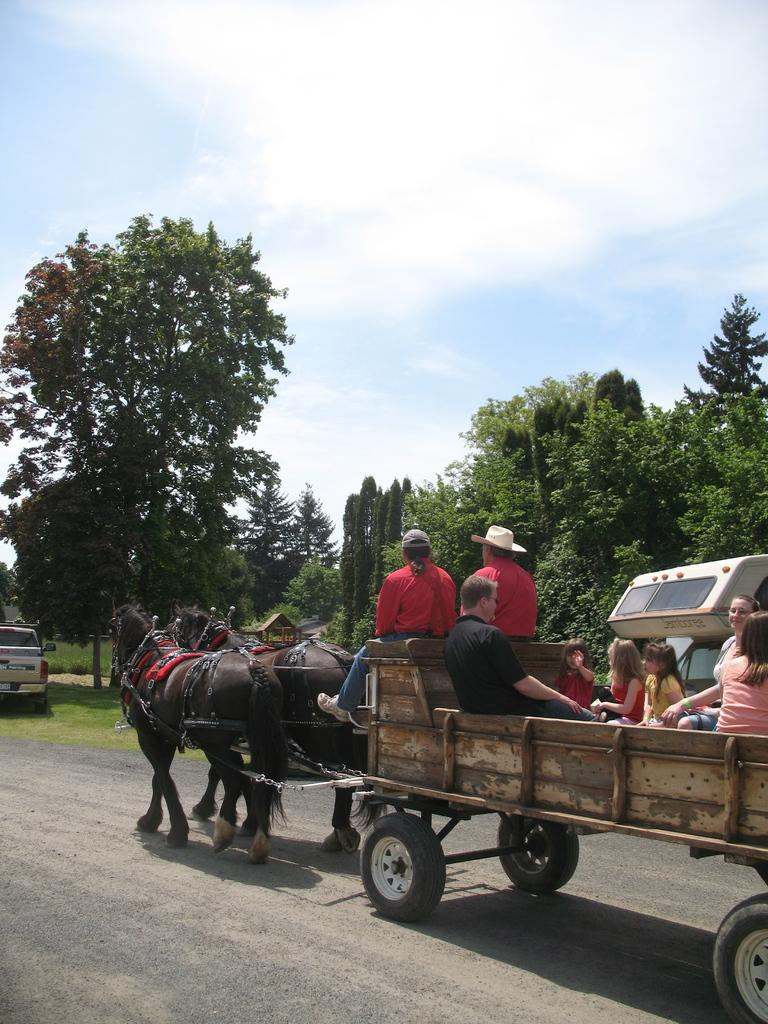What mode of transportation is being used in the image? There is a horse cart in the image. Who is using the horse cart? People are traveling in the horse cart. Where is the horse cart located? The horse cart is on a road. What else can be seen in the image? There is a parked car behind the horse cart, and there are trees around the scene. Can you see any potatoes growing near the horse cart in the image? There are no potatoes visible in the image; it features a horse cart with people traveling on a road surrounded by trees. 